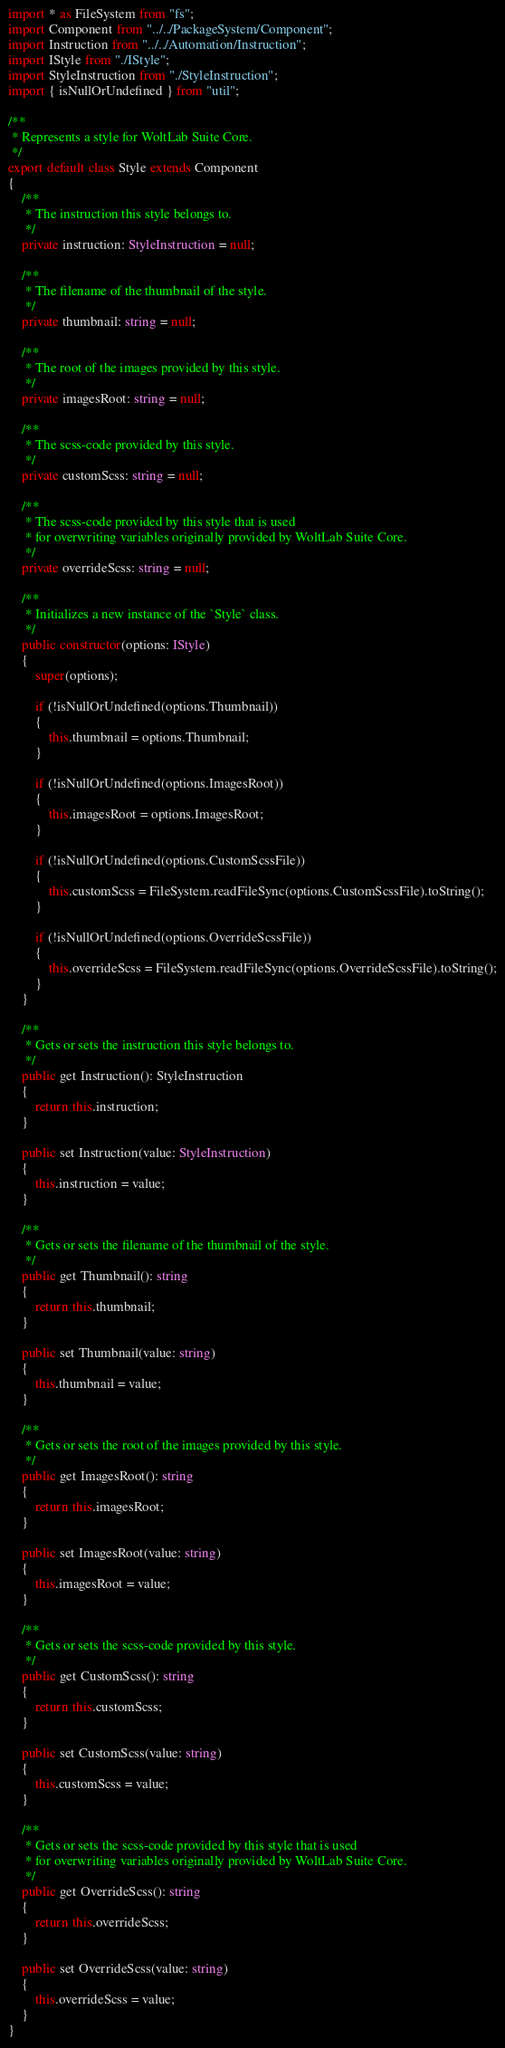<code> <loc_0><loc_0><loc_500><loc_500><_TypeScript_>import * as FileSystem from "fs";
import Component from "../../PackageSystem/Component";
import Instruction from "../../Automation/Instruction";
import IStyle from "./IStyle";
import StyleInstruction from "./StyleInstruction";
import { isNullOrUndefined } from "util";

/**
 * Represents a style for WoltLab Suite Core.
 */
export default class Style extends Component
{
    /**
     * The instruction this style belongs to.
     */
    private instruction: StyleInstruction = null;

    /**
     * The filename of the thumbnail of the style.
     */
    private thumbnail: string = null;

    /**
     * The root of the images provided by this style.
     */
    private imagesRoot: string = null;

    /**
     * The scss-code provided by this style.
     */
    private customScss: string = null;

    /**
     * The scss-code provided by this style that is used
     * for overwriting variables originally provided by WoltLab Suite Core.
     */
    private overrideScss: string = null;

    /**
     * Initializes a new instance of the `Style` class.
     */
    public constructor(options: IStyle)
    {
        super(options);
    
        if (!isNullOrUndefined(options.Thumbnail))
        {
            this.thumbnail = options.Thumbnail;
        }

        if (!isNullOrUndefined(options.ImagesRoot))
        {
            this.imagesRoot = options.ImagesRoot;
        }

        if (!isNullOrUndefined(options.CustomScssFile))
        {
            this.customScss = FileSystem.readFileSync(options.CustomScssFile).toString();
        }

        if (!isNullOrUndefined(options.OverrideScssFile))
        {
            this.overrideScss = FileSystem.readFileSync(options.OverrideScssFile).toString();
        }
    }

    /**
     * Gets or sets the instruction this style belongs to.
     */
    public get Instruction(): StyleInstruction
    {
        return this.instruction;
    }

    public set Instruction(value: StyleInstruction)
    {
        this.instruction = value;
    }

    /**
     * Gets or sets the filename of the thumbnail of the style.
     */
    public get Thumbnail(): string
    {
        return this.thumbnail;
    }

    public set Thumbnail(value: string)
    {
        this.thumbnail = value;
    }

    /**
     * Gets or sets the root of the images provided by this style.
     */
    public get ImagesRoot(): string
    {
        return this.imagesRoot;
    }

    public set ImagesRoot(value: string)
    {
        this.imagesRoot = value;
    }

    /**
     * Gets or sets the scss-code provided by this style.
     */
    public get CustomScss(): string
    {
        return this.customScss;
    }
    
    public set CustomScss(value: string)
    {
        this.customScss = value;
    }
    
    /**
     * Gets or sets the scss-code provided by this style that is used
     * for overwriting variables originally provided by WoltLab Suite Core.
     */
    public get OverrideScss(): string
    {
        return this.overrideScss;
    }

    public set OverrideScss(value: string)
    {
        this.overrideScss = value;
    }
}</code> 